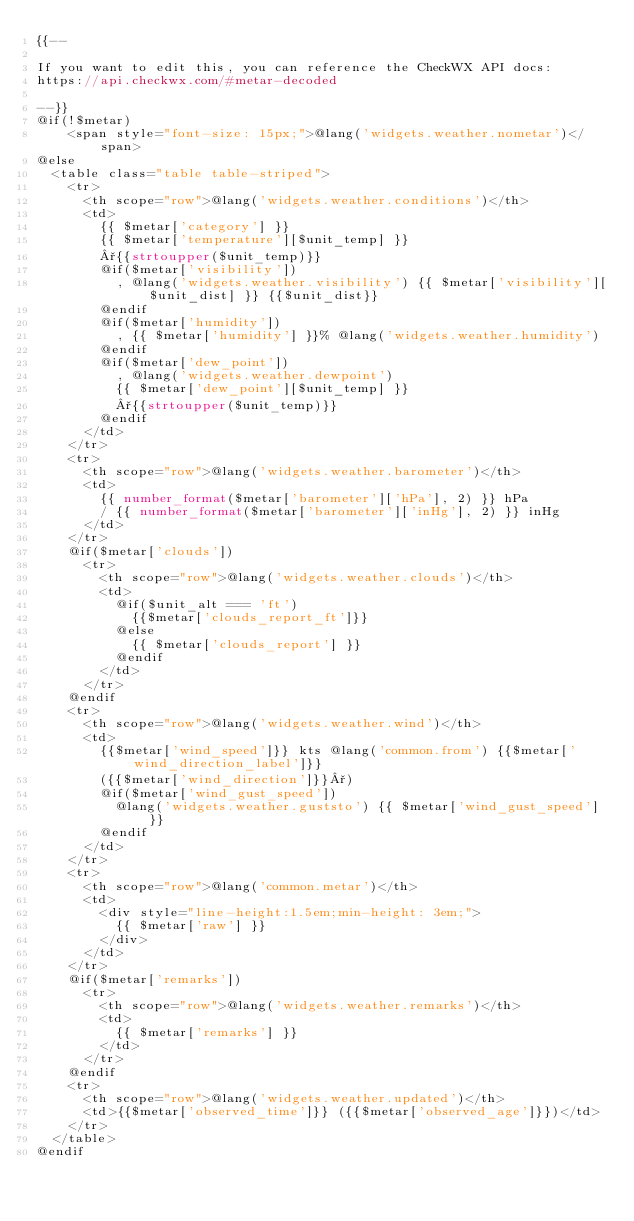<code> <loc_0><loc_0><loc_500><loc_500><_PHP_>{{--

If you want to edit this, you can reference the CheckWX API docs:
https://api.checkwx.com/#metar-decoded

--}}
@if(!$metar)
    <span style="font-size: 15px;">@lang('widgets.weather.nometar')</span>
@else
  <table class="table table-striped">
    <tr>
      <th scope="row">@lang('widgets.weather.conditions')</th>
      <td>
        {{ $metar['category'] }}
        {{ $metar['temperature'][$unit_temp] }}
        °{{strtoupper($unit_temp)}}
        @if($metar['visibility'])
          , @lang('widgets.weather.visibility') {{ $metar['visibility'][$unit_dist] }} {{$unit_dist}}
        @endif
        @if($metar['humidity'])
          , {{ $metar['humidity'] }}% @lang('widgets.weather.humidity')
        @endif
        @if($metar['dew_point'])
          , @lang('widgets.weather.dewpoint')
          {{ $metar['dew_point'][$unit_temp] }}
          °{{strtoupper($unit_temp)}}
        @endif
      </td>
    </tr>
    <tr>
      <th scope="row">@lang('widgets.weather.barometer')</th>
      <td>
        {{ number_format($metar['barometer']['hPa'], 2) }} hPa
        / {{ number_format($metar['barometer']['inHg'], 2) }} inHg
      </td>
    </tr>
    @if($metar['clouds'])
      <tr>
        <th scope="row">@lang('widgets.weather.clouds')</th>
        <td>
          @if($unit_alt === 'ft')
            {{$metar['clouds_report_ft']}}
          @else
            {{ $metar['clouds_report'] }}
          @endif
        </td>
      </tr>
    @endif
    <tr>
      <th scope="row">@lang('widgets.weather.wind')</th>
      <td>
        {{$metar['wind_speed']}} kts @lang('common.from') {{$metar['wind_direction_label']}}
        ({{$metar['wind_direction']}}°)
        @if($metar['wind_gust_speed'])
          @lang('widgets.weather.guststo') {{ $metar['wind_gust_speed'] }}
        @endif
      </td>
    </tr>
    <tr>
      <th scope="row">@lang('common.metar')</th>
      <td>
        <div style="line-height:1.5em;min-height: 3em;">
          {{ $metar['raw'] }}
        </div>
      </td>
    </tr>
    @if($metar['remarks'])
      <tr>
        <th scope="row">@lang('widgets.weather.remarks')</th>
        <td>
          {{ $metar['remarks'] }}
        </td>
      </tr>
    @endif
    <tr>
      <th scope="row">@lang('widgets.weather.updated')</th>
      <td>{{$metar['observed_time']}} ({{$metar['observed_age']}})</td>
    </tr>
  </table>
@endif
</code> 